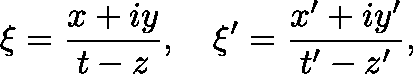<formula> <loc_0><loc_0><loc_500><loc_500>{ \xi } = { \frac { x + i y } { t - z } } , \quad \xi ^ { \prime } = { \frac { x ^ { \prime } + i y ^ { \prime } } { t ^ { \prime } - z ^ { \prime } } } ,</formula> 